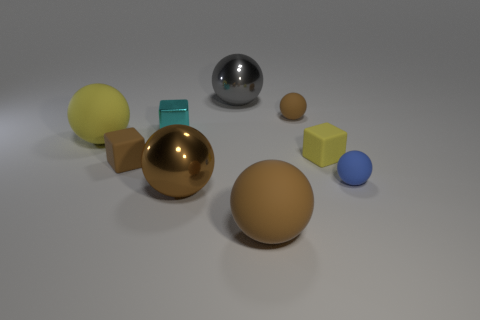Subtract all red cylinders. How many brown spheres are left? 3 Subtract 1 blocks. How many blocks are left? 2 Subtract all yellow balls. How many balls are left? 5 Subtract all big brown metal balls. How many balls are left? 5 Subtract all blue balls. Subtract all gray cubes. How many balls are left? 5 Subtract all blocks. How many objects are left? 6 Add 7 small cyan rubber things. How many small cyan rubber things exist? 7 Subtract 0 purple spheres. How many objects are left? 9 Subtract all large gray spheres. Subtract all cyan metallic things. How many objects are left? 7 Add 7 cyan objects. How many cyan objects are left? 8 